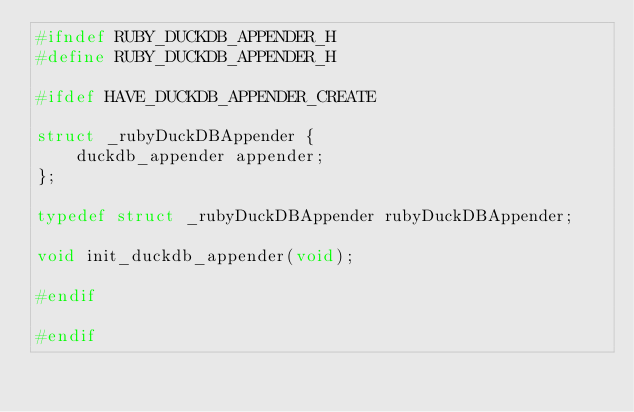<code> <loc_0><loc_0><loc_500><loc_500><_C_>#ifndef RUBY_DUCKDB_APPENDER_H
#define RUBY_DUCKDB_APPENDER_H

#ifdef HAVE_DUCKDB_APPENDER_CREATE

struct _rubyDuckDBAppender {
    duckdb_appender appender;
};

typedef struct _rubyDuckDBAppender rubyDuckDBAppender;

void init_duckdb_appender(void);

#endif

#endif

</code> 